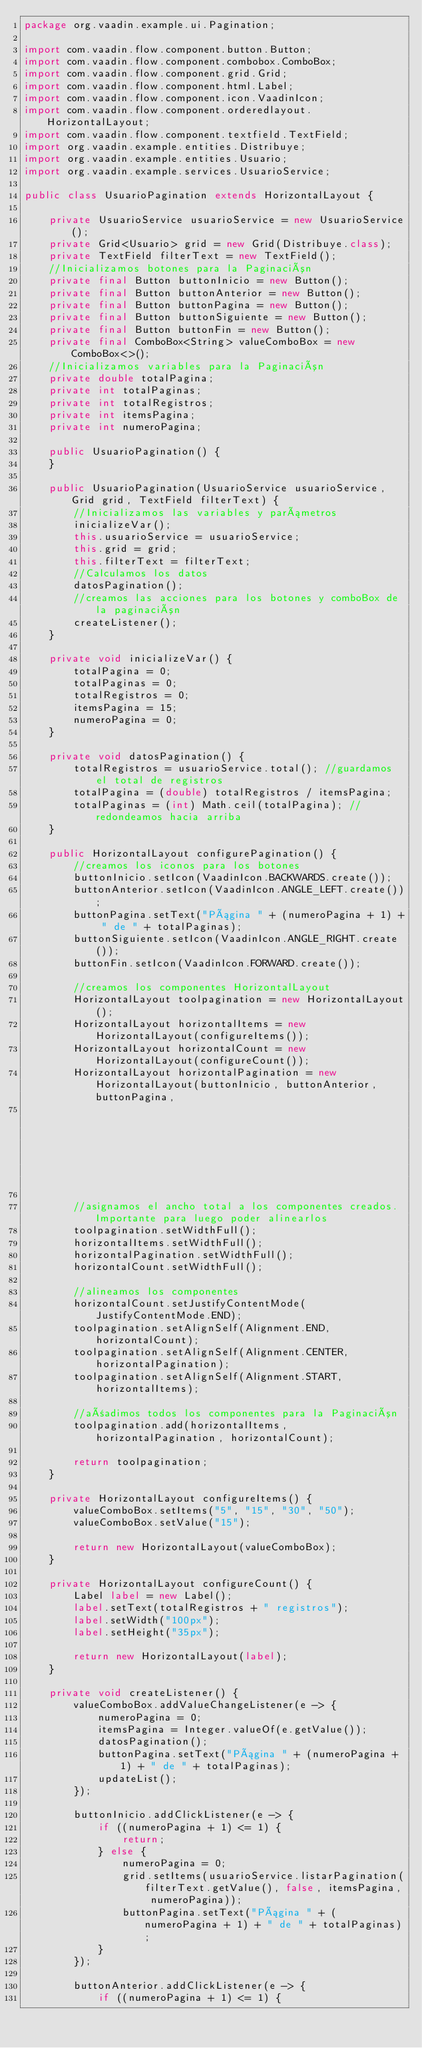Convert code to text. <code><loc_0><loc_0><loc_500><loc_500><_Java_>package org.vaadin.example.ui.Pagination;

import com.vaadin.flow.component.button.Button;
import com.vaadin.flow.component.combobox.ComboBox;
import com.vaadin.flow.component.grid.Grid;
import com.vaadin.flow.component.html.Label;
import com.vaadin.flow.component.icon.VaadinIcon;
import com.vaadin.flow.component.orderedlayout.HorizontalLayout;
import com.vaadin.flow.component.textfield.TextField;
import org.vaadin.example.entities.Distribuye;
import org.vaadin.example.entities.Usuario;
import org.vaadin.example.services.UsuarioService;

public class UsuarioPagination extends HorizontalLayout {

    private UsuarioService usuarioService = new UsuarioService();
    private Grid<Usuario> grid = new Grid(Distribuye.class);
    private TextField filterText = new TextField();
    //Inicializamos botones para la Paginación
    private final Button buttonInicio = new Button();
    private final Button buttonAnterior = new Button();
    private final Button buttonPagina = new Button();
    private final Button buttonSiguiente = new Button();
    private final Button buttonFin = new Button();
    private final ComboBox<String> valueComboBox = new ComboBox<>();
    //Inicializamos variables para la Paginación
    private double totalPagina;
    private int totalPaginas;
    private int totalRegistros;
    private int itemsPagina;
    private int numeroPagina;

    public UsuarioPagination() {
    }

    public UsuarioPagination(UsuarioService usuarioService, Grid grid, TextField filterText) {
        //Inicializamos las variables y parámetros
        inicializeVar();
        this.usuarioService = usuarioService;
        this.grid = grid;
        this.filterText = filterText;
        //Calculamos los datos
        datosPagination();
        //creamos las acciones para los botones y comboBox de la paginación
        createListener();
    }

    private void inicializeVar() {
        totalPagina = 0;
        totalPaginas = 0;
        totalRegistros = 0;
        itemsPagina = 15;
        numeroPagina = 0;
    }

    private void datosPagination() {
        totalRegistros = usuarioService.total(); //guardamos el total de registros
        totalPagina = (double) totalRegistros / itemsPagina;
        totalPaginas = (int) Math.ceil(totalPagina); //redondeamos hacia arriba
    }

    public HorizontalLayout configurePagination() {
        //creamos los iconos para los botones
        buttonInicio.setIcon(VaadinIcon.BACKWARDS.create());
        buttonAnterior.setIcon(VaadinIcon.ANGLE_LEFT.create());
        buttonPagina.setText("Página " + (numeroPagina + 1) + " de " + totalPaginas);
        buttonSiguiente.setIcon(VaadinIcon.ANGLE_RIGHT.create());
        buttonFin.setIcon(VaadinIcon.FORWARD.create());

        //creamos los componentes HorizontalLayout
        HorizontalLayout toolpagination = new HorizontalLayout();
        HorizontalLayout horizontalItems = new HorizontalLayout(configureItems());
        HorizontalLayout horizontalCount = new HorizontalLayout(configureCount());
        HorizontalLayout horizontalPagination = new HorizontalLayout(buttonInicio, buttonAnterior, buttonPagina,
                                                                     buttonSiguiente, buttonFin);

        //asignamos el ancho total a los componentes creados. Importante para luego poder alinearlos
        toolpagination.setWidthFull();
        horizontalItems.setWidthFull();
        horizontalPagination.setWidthFull();
        horizontalCount.setWidthFull();

        //alineamos los componentes
        horizontalCount.setJustifyContentMode(JustifyContentMode.END);
        toolpagination.setAlignSelf(Alignment.END, horizontalCount);
        toolpagination.setAlignSelf(Alignment.CENTER, horizontalPagination);
        toolpagination.setAlignSelf(Alignment.START, horizontalItems);

        //añadimos todos los componentes para la Paginación
        toolpagination.add(horizontalItems, horizontalPagination, horizontalCount);

        return toolpagination;
    }

    private HorizontalLayout configureItems() {
        valueComboBox.setItems("5", "15", "30", "50");
        valueComboBox.setValue("15");

        return new HorizontalLayout(valueComboBox);
    }

    private HorizontalLayout configureCount() {
        Label label = new Label();
        label.setText(totalRegistros + " registros");
        label.setWidth("100px");
        label.setHeight("35px");

        return new HorizontalLayout(label);
    }

    private void createListener() {
        valueComboBox.addValueChangeListener(e -> {
            numeroPagina = 0;
            itemsPagina = Integer.valueOf(e.getValue());
            datosPagination();
            buttonPagina.setText("Página " + (numeroPagina + 1) + " de " + totalPaginas);
            updateList();
        });

        buttonInicio.addClickListener(e -> {
            if ((numeroPagina + 1) <= 1) {
                return;
            } else {
                numeroPagina = 0;
                grid.setItems(usuarioService.listarPagination(filterText.getValue(), false, itemsPagina, numeroPagina));
                buttonPagina.setText("Página " + (numeroPagina + 1) + " de " + totalPaginas);
            }
        });

        buttonAnterior.addClickListener(e -> {
            if ((numeroPagina + 1) <= 1) {</code> 